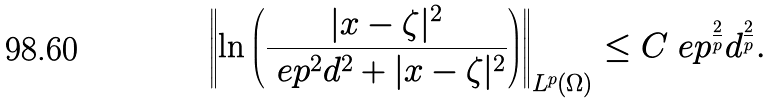Convert formula to latex. <formula><loc_0><loc_0><loc_500><loc_500>\left \| \ln \left ( \frac { | x - \zeta | ^ { 2 } } { \ e p ^ { 2 } d ^ { 2 } + | x - \zeta | ^ { 2 } } \right ) \right \| _ { L ^ { p } ( \Omega ) } \leq C \ e p ^ { \frac { 2 } { p } } d ^ { \frac { 2 } { p } } .</formula> 